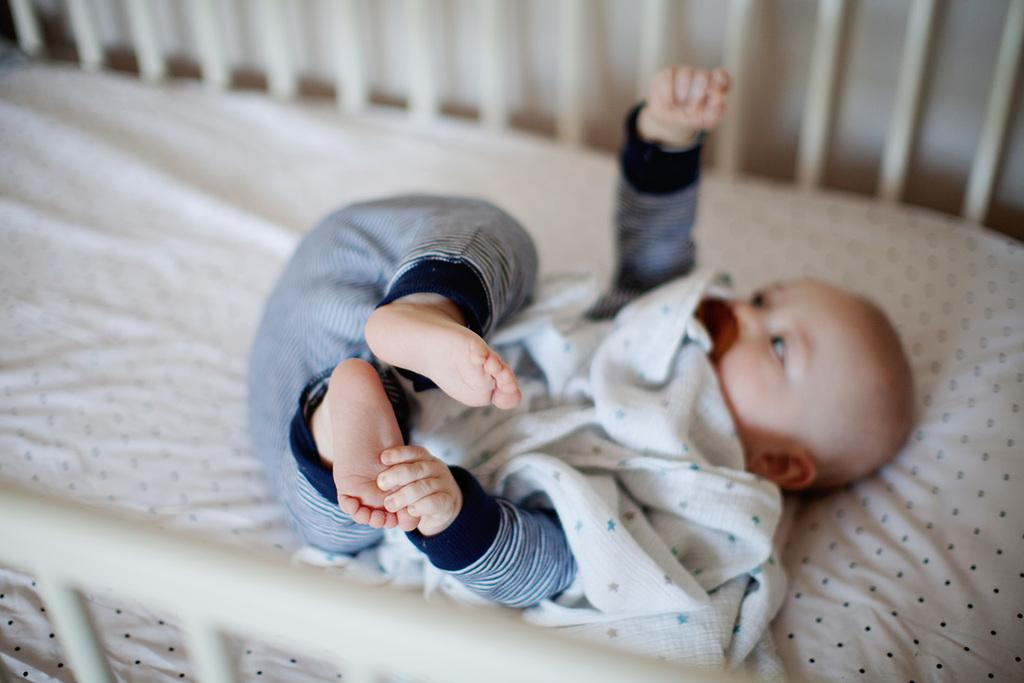What is the main subject of the image? There is a baby in the image. Where is the baby located in the image? The baby is lying in a bed. What type of cart is being used to transport the baby to the sky in the image? There is no cart or sky present in the image; it only features a baby lying in a bed. 